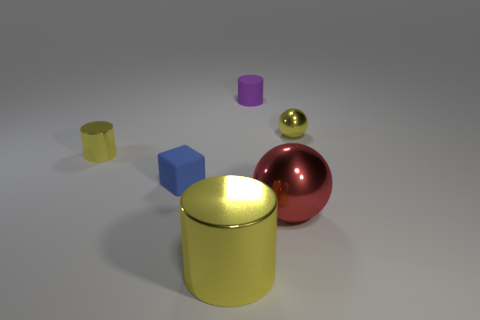What size is the other sphere that is the same material as the big red sphere?
Keep it short and to the point. Small. Is the number of objects that are behind the purple cylinder greater than the number of brown spheres?
Keep it short and to the point. No. There is a small purple object; is its shape the same as the small yellow thing that is to the right of the big yellow cylinder?
Ensure brevity in your answer.  No. How many large objects are either red balls or yellow shiny cylinders?
Ensure brevity in your answer.  2. What is the size of the other cylinder that is the same color as the big metal cylinder?
Make the answer very short. Small. There is a small metal thing that is in front of the tiny yellow object that is right of the big red metal sphere; what is its color?
Make the answer very short. Yellow. Are the tiny blue thing and the red sphere that is in front of the tiny yellow metallic ball made of the same material?
Ensure brevity in your answer.  No. What is the small yellow object left of the tiny purple rubber thing made of?
Provide a succinct answer. Metal. Are there an equal number of tiny purple rubber objects in front of the big yellow metallic cylinder and red shiny cubes?
Provide a succinct answer. Yes. Is there any other thing that is the same size as the red sphere?
Your answer should be compact. Yes. 